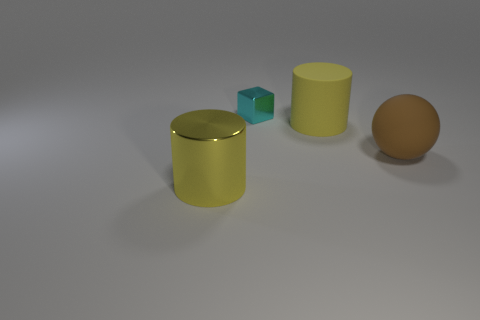Are there any other things that are the same size as the cyan thing?
Keep it short and to the point. No. What shape is the large rubber thing that is the same color as the large metallic cylinder?
Provide a succinct answer. Cylinder. Are there fewer rubber cylinders that are left of the brown thing than large yellow metal objects on the left side of the small cyan thing?
Your answer should be compact. No. The big rubber cylinder has what color?
Your response must be concise. Yellow. Is there a large brown matte ball behind the tiny cyan metallic thing that is behind the metal cylinder?
Your answer should be compact. No. How many brown spheres are the same size as the yellow metal cylinder?
Your answer should be very brief. 1. There is a big yellow cylinder that is in front of the big yellow object that is behind the large yellow shiny cylinder; how many big brown rubber things are to the right of it?
Provide a succinct answer. 1. What number of matte objects are right of the big yellow rubber object and left of the brown sphere?
Ensure brevity in your answer.  0. Is there anything else that is the same color as the metal cylinder?
Offer a terse response. Yes. How many matte objects are green blocks or big yellow things?
Your answer should be very brief. 1. 